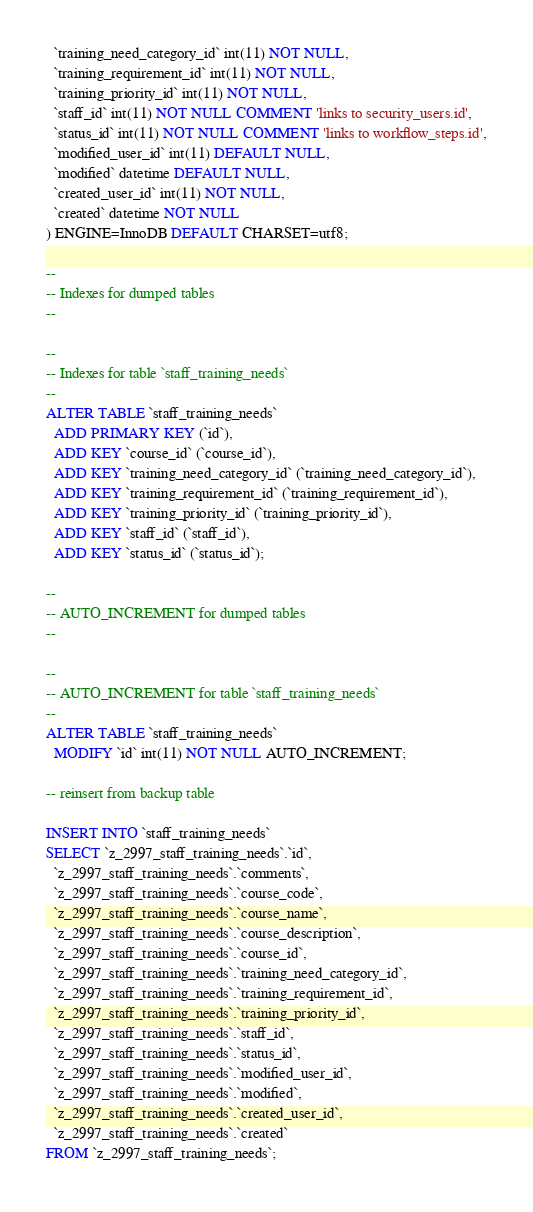Convert code to text. <code><loc_0><loc_0><loc_500><loc_500><_SQL_>  `training_need_category_id` int(11) NOT NULL,
  `training_requirement_id` int(11) NOT NULL,
  `training_priority_id` int(11) NOT NULL,
  `staff_id` int(11) NOT NULL COMMENT 'links to security_users.id',
  `status_id` int(11) NOT NULL COMMENT 'links to workflow_steps.id',
  `modified_user_id` int(11) DEFAULT NULL,
  `modified` datetime DEFAULT NULL,
  `created_user_id` int(11) NOT NULL,
  `created` datetime NOT NULL
) ENGINE=InnoDB DEFAULT CHARSET=utf8;

--
-- Indexes for dumped tables
--

--
-- Indexes for table `staff_training_needs`
--
ALTER TABLE `staff_training_needs`
  ADD PRIMARY KEY (`id`),
  ADD KEY `course_id` (`course_id`),
  ADD KEY `training_need_category_id` (`training_need_category_id`),
  ADD KEY `training_requirement_id` (`training_requirement_id`),
  ADD KEY `training_priority_id` (`training_priority_id`),
  ADD KEY `staff_id` (`staff_id`),
  ADD KEY `status_id` (`status_id`);

--
-- AUTO_INCREMENT for dumped tables
--

--
-- AUTO_INCREMENT for table `staff_training_needs`
--
ALTER TABLE `staff_training_needs`
  MODIFY `id` int(11) NOT NULL AUTO_INCREMENT;

-- reinsert from backup table

INSERT INTO `staff_training_needs`
SELECT `z_2997_staff_training_needs`.`id`, 
  `z_2997_staff_training_needs`.`comments`, 
  `z_2997_staff_training_needs`.`course_code`, 
  `z_2997_staff_training_needs`.`course_name`, 
  `z_2997_staff_training_needs`.`course_description`,
  `z_2997_staff_training_needs`.`course_id`, 
  `z_2997_staff_training_needs`.`training_need_category_id`, 
  `z_2997_staff_training_needs`.`training_requirement_id`,
  `z_2997_staff_training_needs`.`training_priority_id`, 
  `z_2997_staff_training_needs`.`staff_id`, 
  `z_2997_staff_training_needs`.`status_id`,
  `z_2997_staff_training_needs`.`modified_user_id`, 
  `z_2997_staff_training_needs`.`modified`, 
  `z_2997_staff_training_needs`.`created_user_id`, 
  `z_2997_staff_training_needs`.`created` 
FROM `z_2997_staff_training_needs`;</code> 